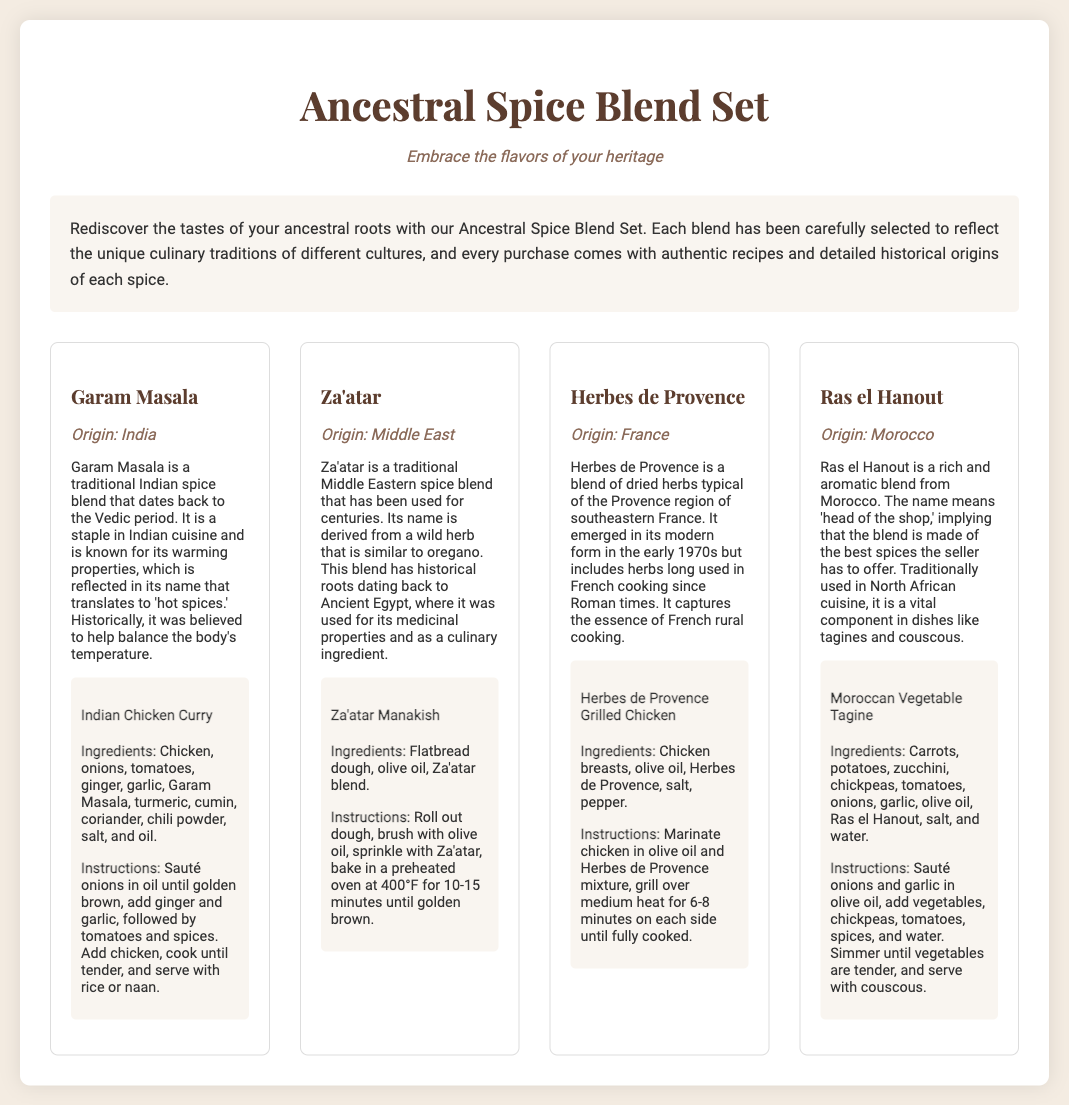What is the tagline of the Ancestral Spice Blend Set? The tagline emphasizes embracing heritage flavors, as stated directly in the document.
Answer: Embrace the flavors of your heritage What spice is known for its warming properties? The document specifically refers to Garam Masala and its warming properties in its description.
Answer: Garam Masala What is the origin of Za'atar? The document clearly specifies that Za'atar originates from the Middle East.
Answer: Middle East What dish can be made with Herbes de Provence? The document provides a specific recipe featuring this spice which involves grilled chicken.
Answer: Herbes de Provence Grilled Chicken How many spices are included in the Ancestral Spice Blend Set? By counting the spices listed in the document, we can easily determine the total number.
Answer: Four What does Ras el Hanout mean? The document explains that the name means 'head of the shop.'
Answer: Head of the shop Which spice blend has historical roots dating back to Ancient Egypt? The context in the document indicates that Za'atar is tied to Ancient Egyptian roots.
Answer: Za'atar What is the main ingredient in the Moroccan Vegetable Tagine recipe? The ingredients listed in the document specify that vegetables are the main component here.
Answer: Vegetables 